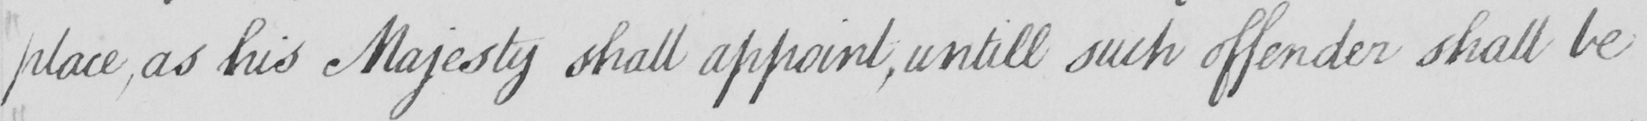What text is written in this handwritten line? place  , as his Majesty shall appoint  , untill such offender shall be 